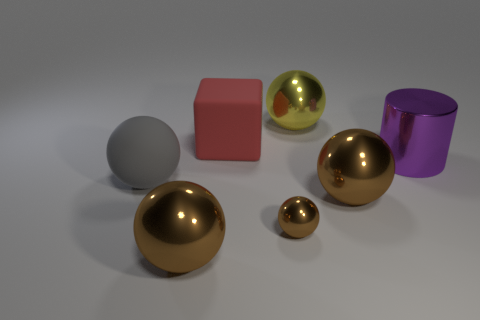What number of tiny cyan metallic things are the same shape as the yellow metal thing?
Offer a terse response. 0. What shape is the big yellow metal object?
Offer a terse response. Sphere. Are there an equal number of tiny brown metallic objects that are on the left side of the tiny brown thing and tiny green metal blocks?
Provide a short and direct response. Yes. Is there any other thing that has the same material as the tiny brown ball?
Offer a terse response. Yes. Are the big sphere that is behind the big gray ball and the tiny sphere made of the same material?
Give a very brief answer. Yes. Is the number of red things that are right of the purple metal thing less than the number of small purple shiny objects?
Offer a very short reply. No. How many metallic things are gray spheres or red things?
Your answer should be very brief. 0. Does the cylinder have the same color as the cube?
Your answer should be compact. No. Is there any other thing of the same color as the large rubber block?
Ensure brevity in your answer.  No. There is a brown thing that is on the right side of the small metal object; does it have the same shape as the large matte thing in front of the large purple metal thing?
Give a very brief answer. Yes. 